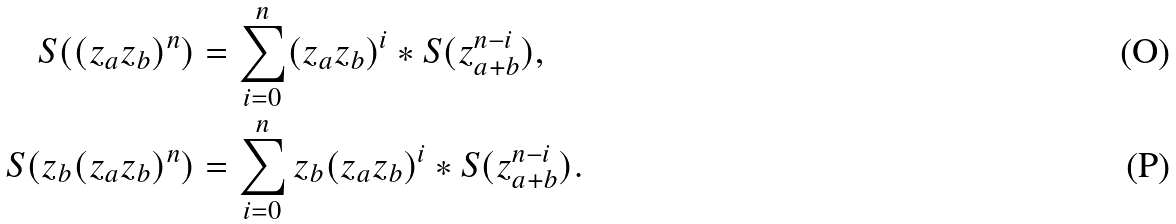Convert formula to latex. <formula><loc_0><loc_0><loc_500><loc_500>S ( ( z _ { a } z _ { b } ) ^ { n } ) & = \sum _ { i = 0 } ^ { n } ( z _ { a } z _ { b } ) ^ { i } * S ( z _ { a + b } ^ { n - i } ) , \\ S ( z _ { b } ( z _ { a } z _ { b } ) ^ { n } ) & = \sum _ { i = 0 } ^ { n } z _ { b } ( z _ { a } z _ { b } ) ^ { i } * S ( z _ { a + b } ^ { n - i } ) .</formula> 